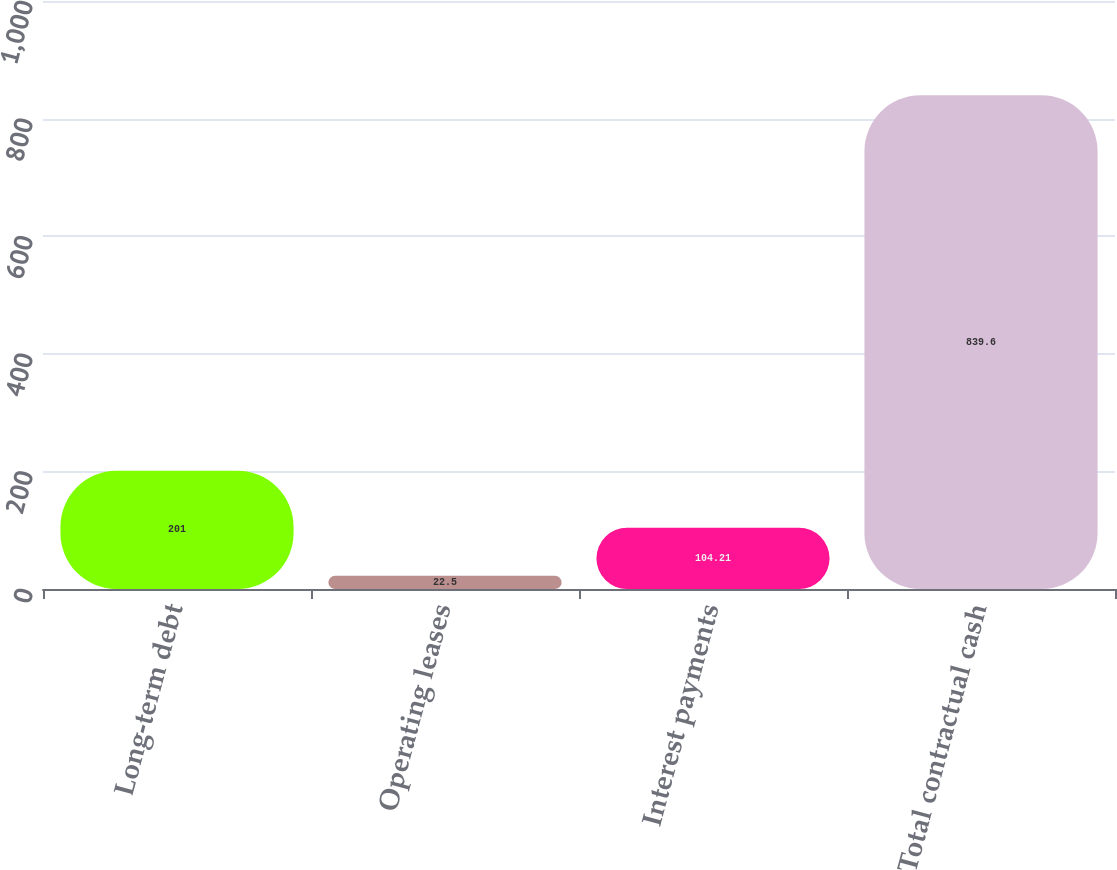Convert chart. <chart><loc_0><loc_0><loc_500><loc_500><bar_chart><fcel>Long-term debt<fcel>Operating leases<fcel>Interest payments<fcel>Total contractual cash<nl><fcel>201<fcel>22.5<fcel>104.21<fcel>839.6<nl></chart> 